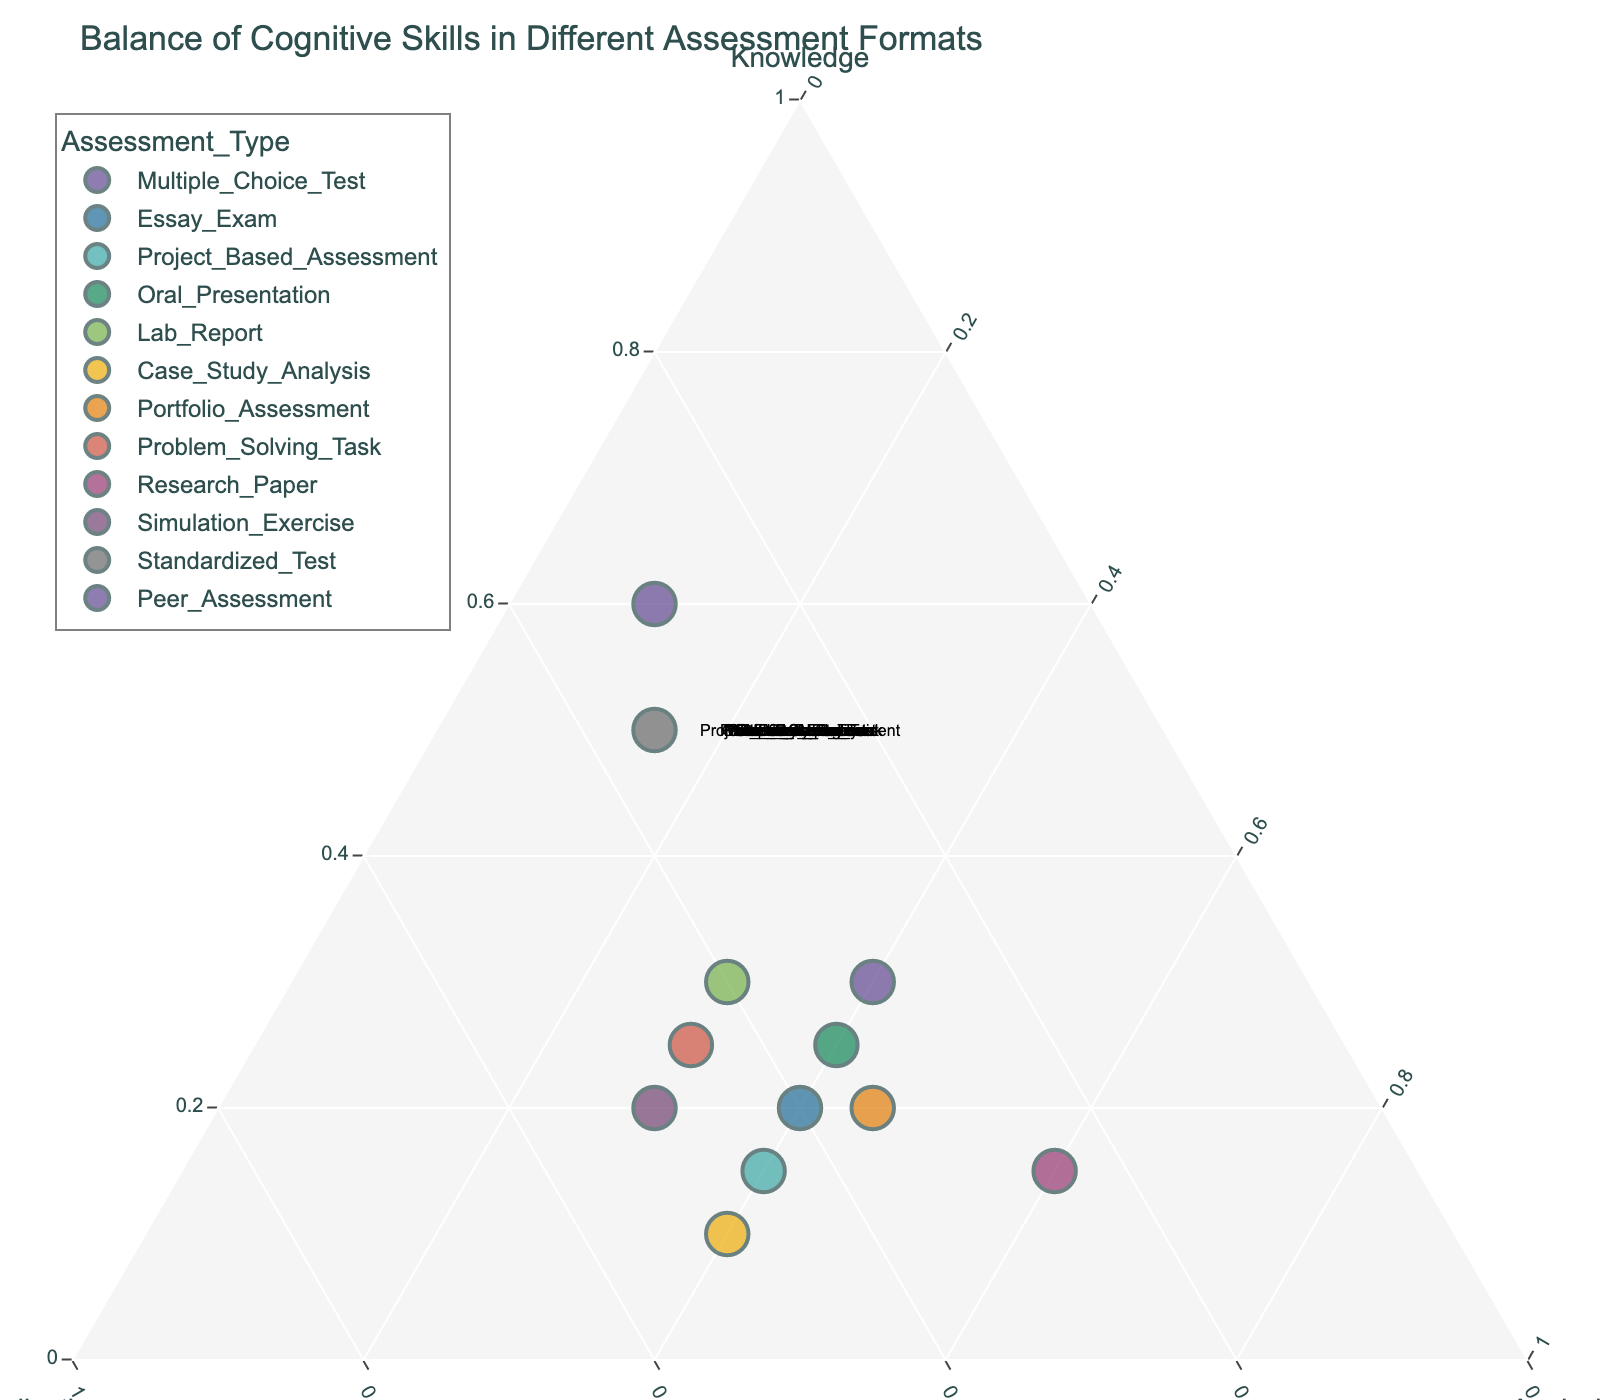What is the title of the ternary plot? The title is located at the top of the figure.
Answer: Balance of Cognitive Skills in Different Assessment Formats How many data points are shown in the ternary plot? Count the number of different assessment types represented by their markers in the plot.
Answer: 12 Which assessment type has the highest percentage of knowledge-based evaluation? Look for the data point closest to the "Knowledge" vertex.
Answer: Multiple Choice Test Which assessment type balances Application and Analysis equally with 50% and 50% respectively? Calculate which data point has both Application and Analysis making up 50% when combined. As all points are constrained to sum to 100%, the remaining will be knowledge.
Answer: No such assessment type How many assessments types focus 40% on Analysis? Count the number of data points where the Analysis component is identified as 40%.
Answer: 5 Which assessment type focuses the most on Application skills? Find the data point closest to the "Application" vertex which signifies the highest focus on Application.
Answer: Case Study Analysis Compare the Project-Based Assessment and Lab Report: Which has a higher application percentage? Check the coordinates of both assessments and compare their Application value.
Answer: Project-Based Assessment What's the average percentage of knowledge across all the assessment types? Sum all the Knowledge percentages and then divide by the number of assessment types. (60+20+15+25+30+10+20+25+15+20+50+30)/12 = 25
Answer: 25 Identify the assessment type closest to a balanced distribution of cognitive skills. Look for the data point nearest to the center of the plot, implying a balance among Knowledge, Analysis, and Application.
Answer: Lab Report Is there any assessment type where the Analysis component is higher than both Knowledge and Application? If yes, which one? Check the data points to see if Analysis is the highest percentage component in any assessment type.
Answer: Research Paper 